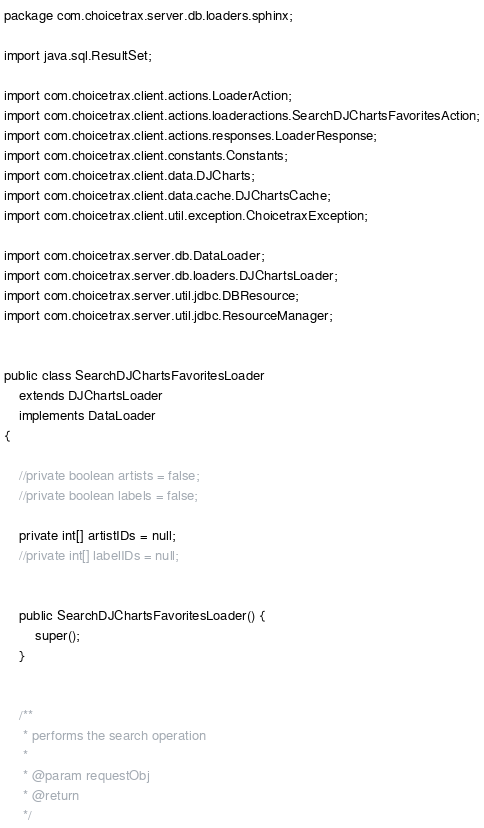Convert code to text. <code><loc_0><loc_0><loc_500><loc_500><_Java_>package com.choicetrax.server.db.loaders.sphinx;

import java.sql.ResultSet;

import com.choicetrax.client.actions.LoaderAction;
import com.choicetrax.client.actions.loaderactions.SearchDJChartsFavoritesAction;
import com.choicetrax.client.actions.responses.LoaderResponse;
import com.choicetrax.client.constants.Constants;
import com.choicetrax.client.data.DJCharts;
import com.choicetrax.client.data.cache.DJChartsCache;
import com.choicetrax.client.util.exception.ChoicetraxException;

import com.choicetrax.server.db.DataLoader;
import com.choicetrax.server.db.loaders.DJChartsLoader;
import com.choicetrax.server.util.jdbc.DBResource;
import com.choicetrax.server.util.jdbc.ResourceManager;


public class SearchDJChartsFavoritesLoader 
	extends DJChartsLoader
	implements DataLoader
{
	
	//private boolean artists = false;
	//private boolean labels = false;
	
	private int[] artistIDs = null;
	//private int[] labelIDs = null;
	
	
	public SearchDJChartsFavoritesLoader() {
		super();
	}
	
	
	/**
	 * performs the search operation
	 * 
	 * @param requestObj
	 * @return
	 */</code> 